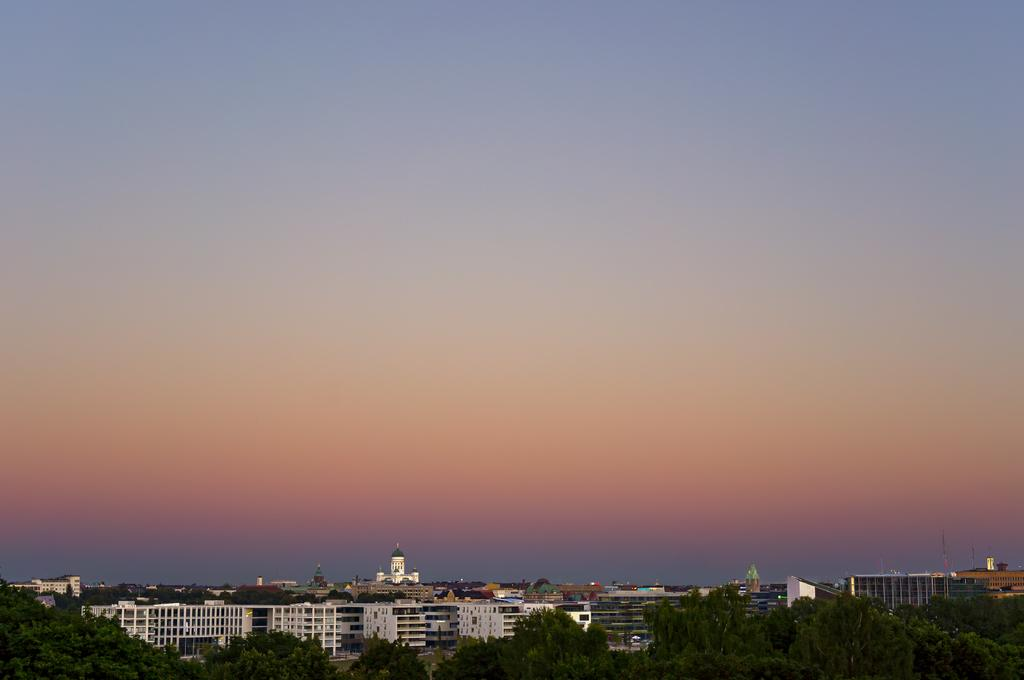Where was the image taken? The image was clicked outside the city. What can be seen in the foreground of the image? There are trees in the foreground of the image. What type of structures are visible in the center of the image? There are buildings and towers in the center of the image. What part of the natural environment is visible in the image? The sky is visible in the image. Can you see a record player in the image? There is no record player present in the image. Is there a giraffe visible in the image? There is no giraffe present in the image. 